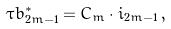Convert formula to latex. <formula><loc_0><loc_0><loc_500><loc_500>\tau b ^ { * } _ { 2 m - 1 } = C _ { m } \cdot i _ { 2 m - 1 } \, ,</formula> 